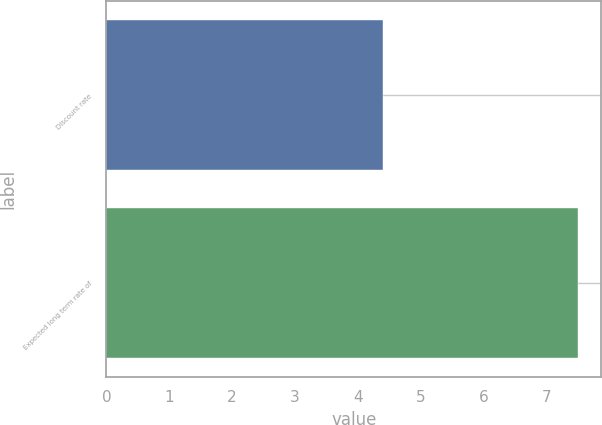Convert chart. <chart><loc_0><loc_0><loc_500><loc_500><bar_chart><fcel>Discount rate<fcel>Expected long term rate of<nl><fcel>4.4<fcel>7.5<nl></chart> 